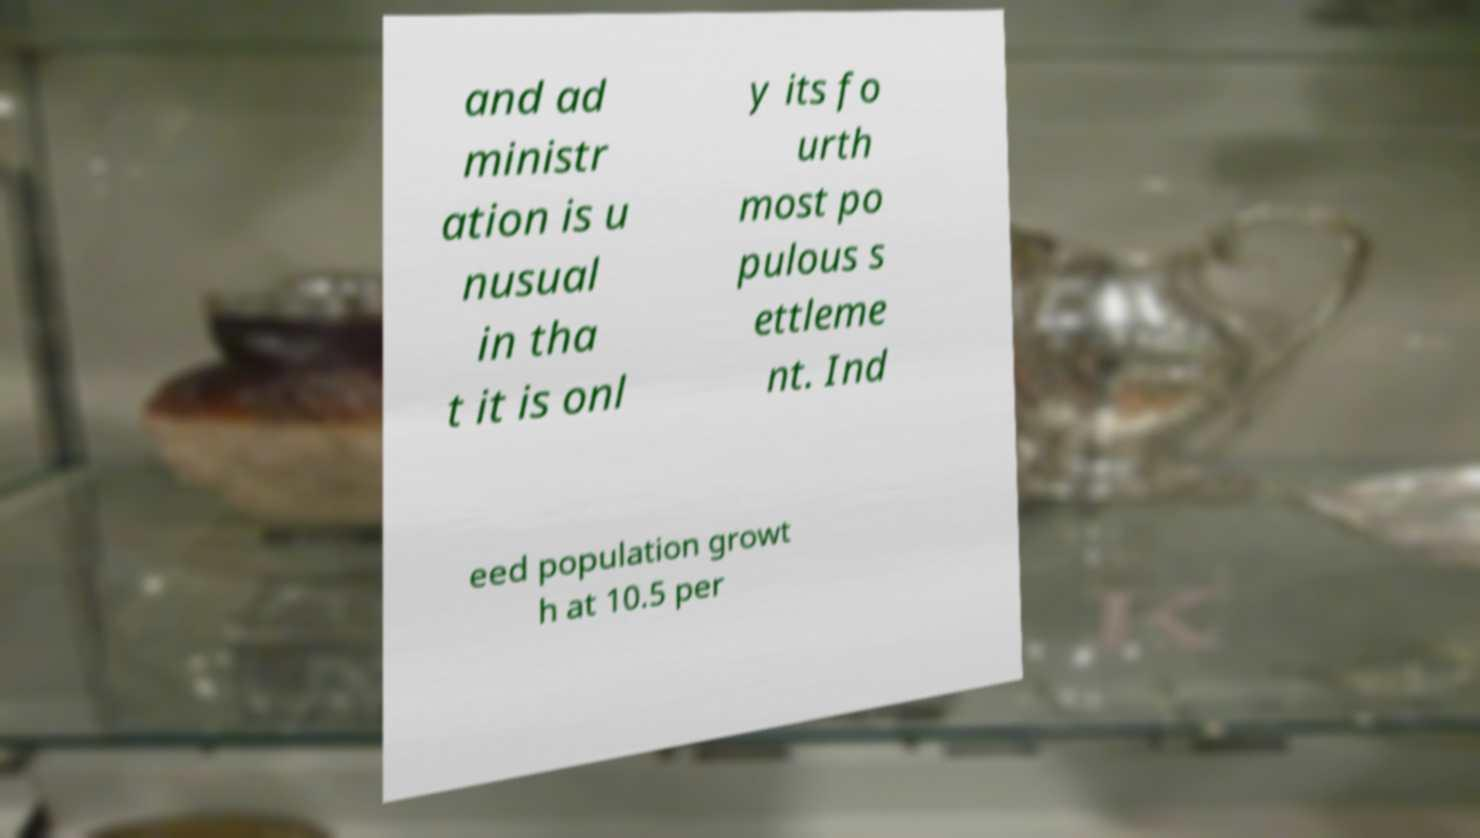There's text embedded in this image that I need extracted. Can you transcribe it verbatim? and ad ministr ation is u nusual in tha t it is onl y its fo urth most po pulous s ettleme nt. Ind eed population growt h at 10.5 per 